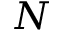<formula> <loc_0><loc_0><loc_500><loc_500>N</formula> 